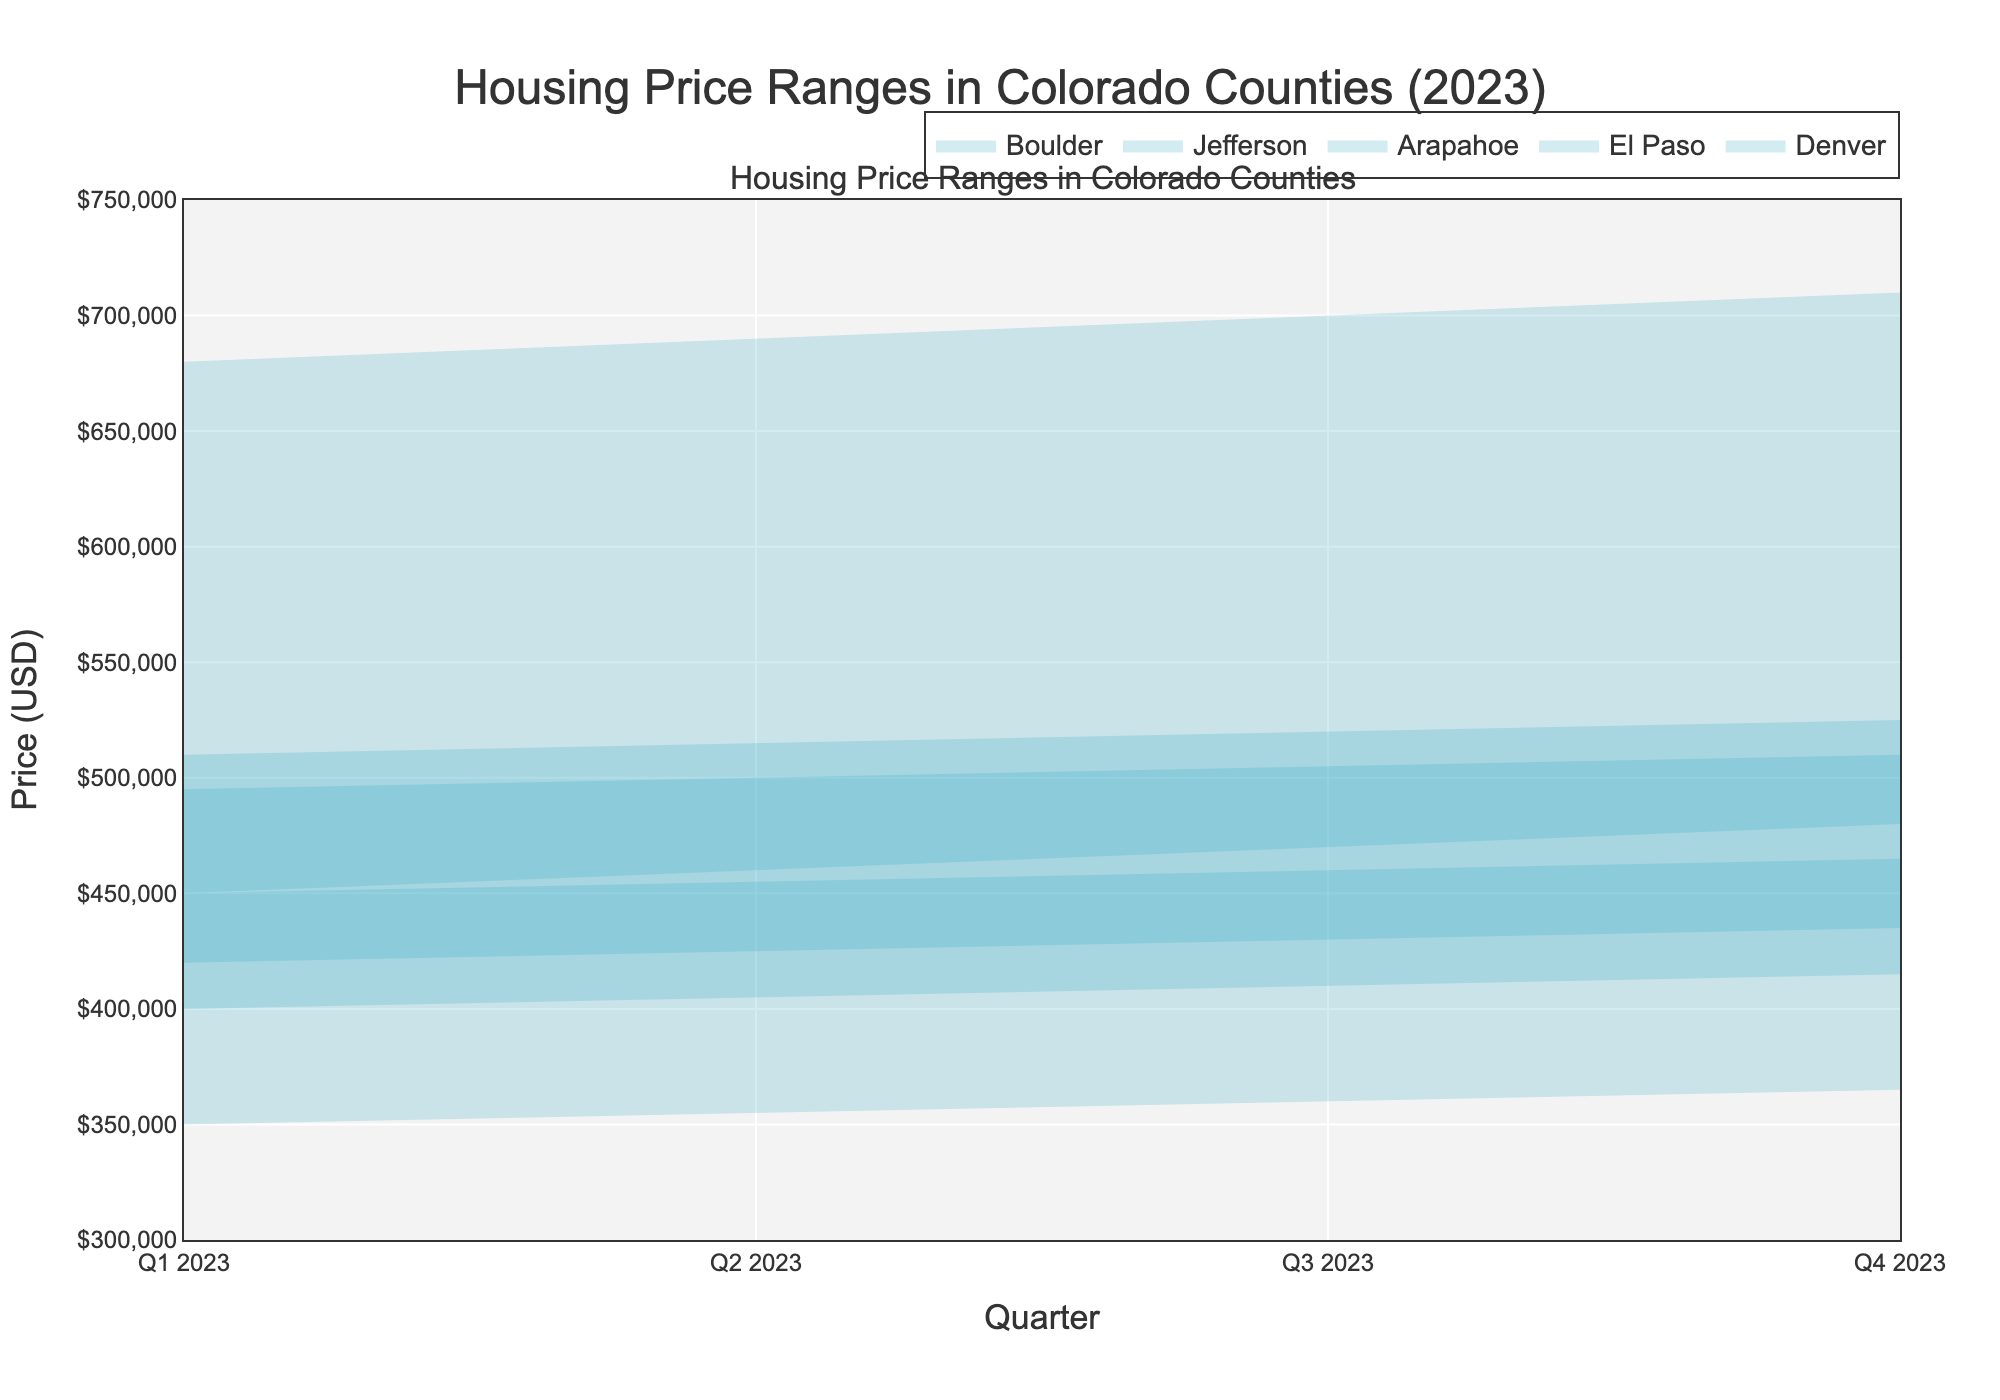What is the price range for Denver in Q1 2023? The figure shows that the minimum price for Denver in Q1 2023 is $450,000 and the maximum price is $550,000.
Answer: $450,000 - $550,000 Which county has the highest maximum housing price in Q4 2023? Looking at the figure for Q4 2023, Boulder has the highest maximum housing price at $710,000.
Answer: Boulder How does the price range in Jefferson County change from Q2 2023 to Q3 2023? In Q2 2023, the range in Jefferson is from $425,000 to $515,000. In Q3 2023, it shifts to $430,000 to $520000. This shows an increase of $5,000 in both minimum and maximum prices.
Answer: Both minimum and maximum increased by $5,000 Which county shows the smallest increase in minimum price from Q1 to Q4 2023? Calculating the difference for each county:
- Denver: $30,000
- El Paso: $15,000
- Arapahoe: $15,000
- Jefferson: $15,000
- Boulder: $30,000
El Paso, Arapahoe, and Jefferson all have an increase of $15,000, being the smallest among the counties.
Answer: El Paso, Arapahoe, Jefferson What is the difference between the maximum prices of Boulder and El Paso in Q3 2023? In Q3 2023, the maximum price for Boulder is $700,000, and for El Paso is $460,000. The difference is $700,000 - $460,000 = $240,000
Answer: $240,000 Which county has shown the most consistent price range (smallest variance) throughout 2023? Examining the figure, El Paso consistently shows a narrow range of $100,000 to $105,000 across all quarters, indicating the smallest variance.
Answer: El Paso From which quarter to which quarter does Boulder show the same increase in maximum price? Boulder increases by $10,000 every quarter, starting from $680,000 in Q1, to $690,000 in Q2, to $700,000 in Q3, and finally to $710,000 in Q4.
Answer: Q1 to Q2, Q2 to Q3, Q3 to Q4 How do the price ranges of El Paso compare to Arapahoe in Q4 2023? In Q4 2023, El Paso has a range from $365,000 to $465,000 and Arapahoe has a range from $415,000 to $510,000. The Arapahoe range is higher by $50,000 on the lower end and higher by $45,000 on the upper end.
Answer: Arapahoe is higher by $50,000 (min) and $45,000 (max) In which quarter does Denver reach or exceed a minimum price of $470,000? Observing the figure, Denver reaches a minimum price of $470,000 in Q3 2023.
Answer: Q3 2023 What is the average maximum price of Boulder across all quarters in 2023? Adding up the maximum prices for Boulder across quarters ($680,000 + $690,000 + $700,000 + $710,000) and dividing by 4 gives an average of ($2,780,000 / 4) = $695,000
Answer: $695,000 